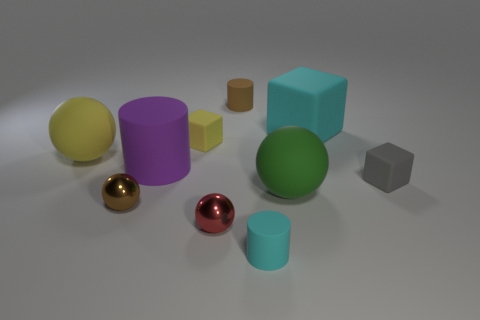Subtract all yellow spheres. How many spheres are left? 3 Subtract 1 spheres. How many spheres are left? 3 Subtract all tiny brown shiny spheres. How many spheres are left? 3 Subtract all blue balls. Subtract all red blocks. How many balls are left? 4 Subtract 0 gray cylinders. How many objects are left? 10 Subtract all spheres. How many objects are left? 6 Subtract all purple cylinders. Subtract all small metallic balls. How many objects are left? 7 Add 6 small cyan objects. How many small cyan objects are left? 7 Add 9 green spheres. How many green spheres exist? 10 